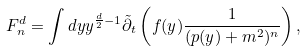Convert formula to latex. <formula><loc_0><loc_0><loc_500><loc_500>F _ { n } ^ { d } = \int d y y ^ { \frac { d } { 2 } - 1 } { \tilde { \partial } _ { t } } \left ( f ( y ) \frac { 1 } { ( p ( y ) + m ^ { 2 } ) ^ { n } } \right ) ,</formula> 